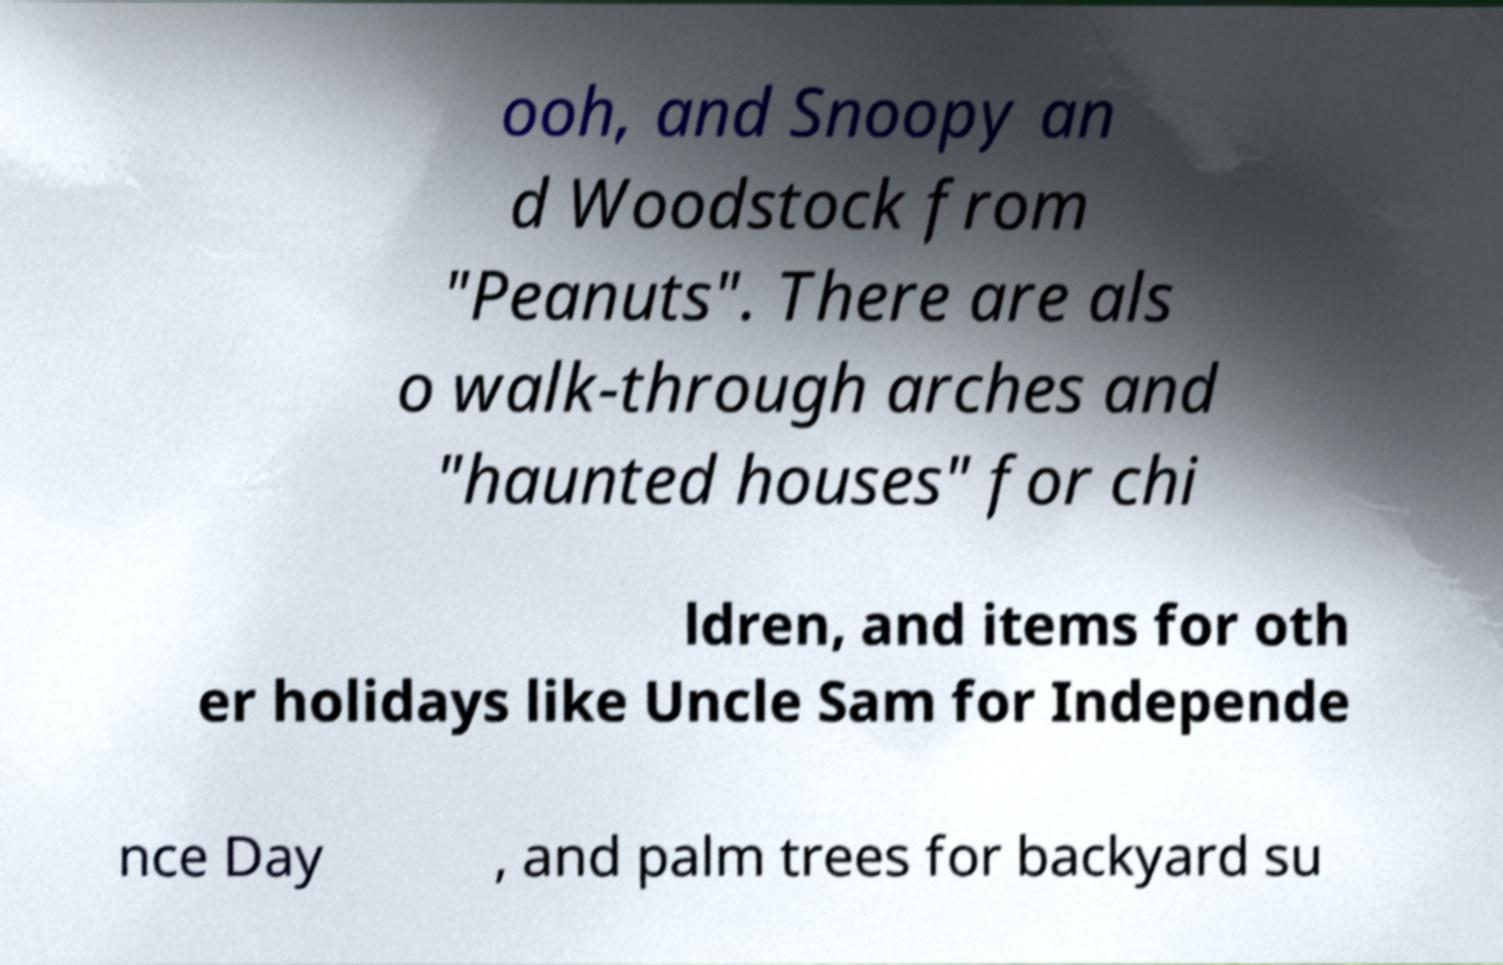There's text embedded in this image that I need extracted. Can you transcribe it verbatim? ooh, and Snoopy an d Woodstock from "Peanuts". There are als o walk-through arches and "haunted houses" for chi ldren, and items for oth er holidays like Uncle Sam for Independe nce Day , and palm trees for backyard su 